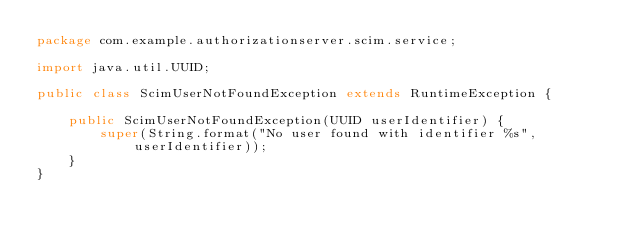Convert code to text. <code><loc_0><loc_0><loc_500><loc_500><_Java_>package com.example.authorizationserver.scim.service;

import java.util.UUID;

public class ScimUserNotFoundException extends RuntimeException {

    public ScimUserNotFoundException(UUID userIdentifier) {
        super(String.format("No user found with identifier %s", userIdentifier));
    }
}
</code> 